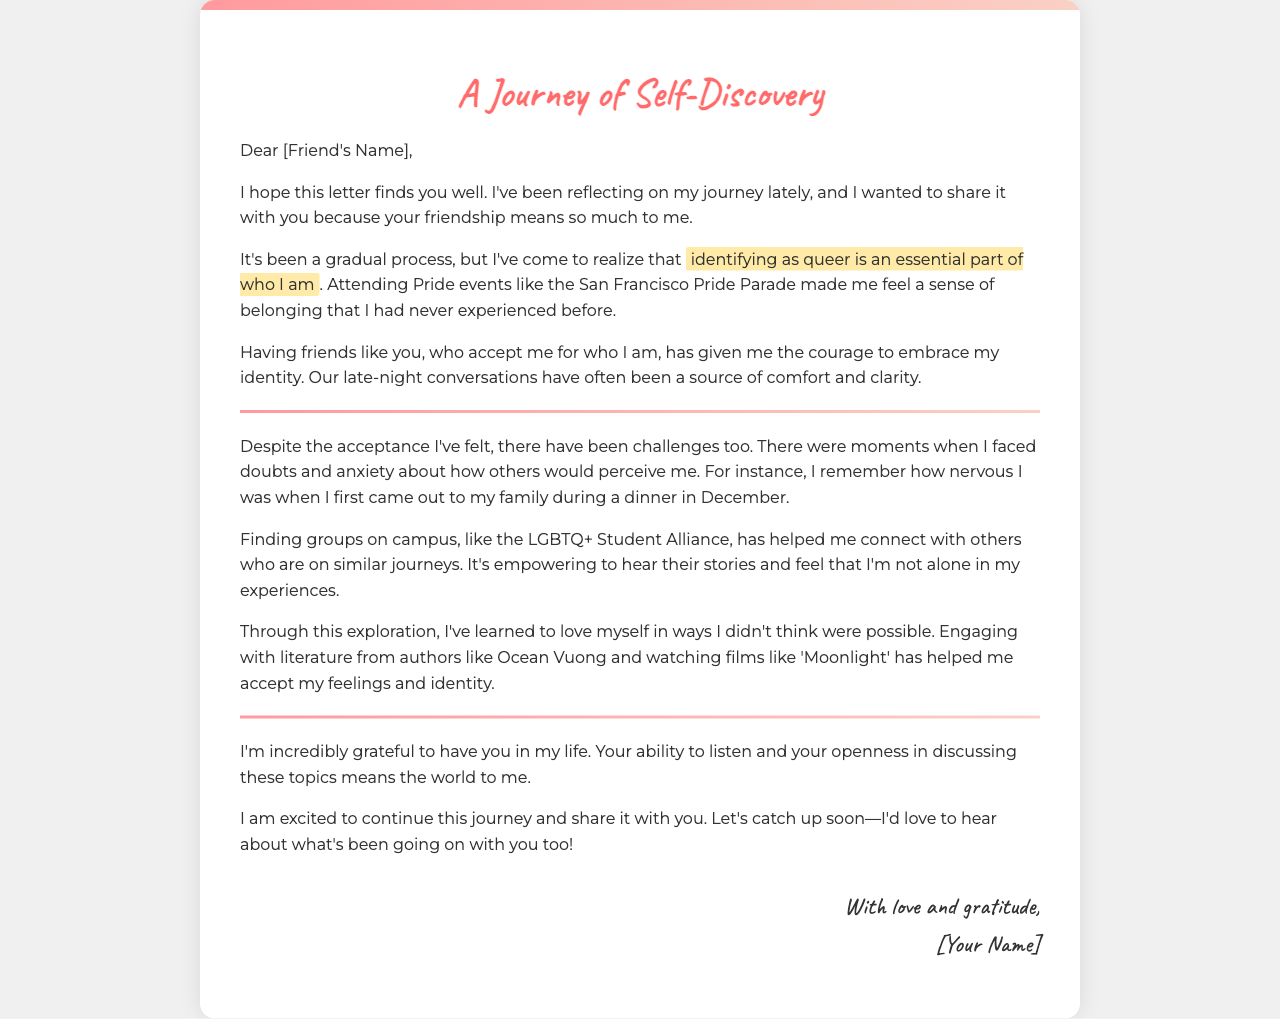What is the title of the letter? The title is found at the top of the letter and indicates the main subject being discussed.
Answer: A Journey of Self-Discovery Who is the letter addressed to? The opening of the letter typically includes the recipient's name.
Answer: [Friend's Name] Which event made the author feel a sense of belonging? The letter mentions a specific event that had a significant impact on the author's feelings of acceptance.
Answer: San Francisco Pride Parade What group on campus helped the author connect with others? The letter references a specific student organization that facilitated connection for the author.
Answer: LGBTQ+ Student Alliance What authors' works helped the author in their journey? The letter includes the names of authors that were influential in shaping the author's understanding of their identity.
Answer: Ocean Vuong What type of issues did the author face during their self-discovery? The letter describes specific personal challenges that the author encountered while exploring their identity.
Answer: Doubts and anxiety How does the author feel about their journey? The latter portion of the letter reflects the author's overall sentiment regarding their self-discovery process.
Answer: Excited 